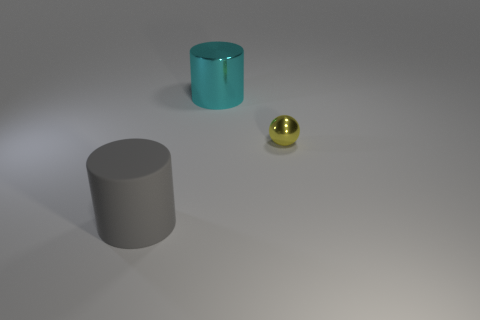There is a thing in front of the shiny thing that is in front of the big object that is behind the gray cylinder; what is it made of?
Provide a short and direct response. Rubber. Do the tiny yellow ball and the big cylinder that is to the right of the matte thing have the same material?
Offer a very short reply. Yes. There is another big thing that is the same shape as the big rubber thing; what is its material?
Keep it short and to the point. Metal. Are there any other things that have the same material as the cyan cylinder?
Your answer should be very brief. Yes. Are there more big cyan metal cylinders that are behind the big cyan cylinder than small balls that are in front of the gray matte cylinder?
Make the answer very short. No. What is the shape of the cyan thing that is made of the same material as the yellow object?
Offer a terse response. Cylinder. How many other objects are there of the same shape as the small metal thing?
Your answer should be very brief. 0. The shiny object that is behind the small yellow metal sphere has what shape?
Your response must be concise. Cylinder. The sphere has what color?
Your answer should be compact. Yellow. What number of other things are the same size as the rubber cylinder?
Your response must be concise. 1. 